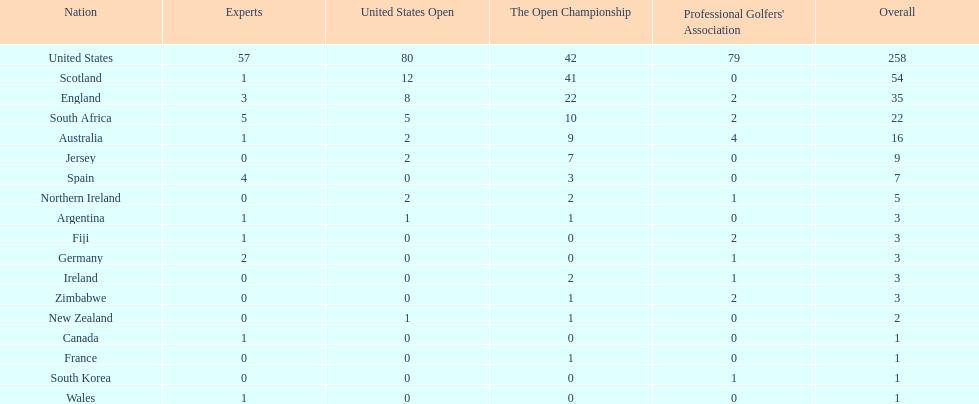In how many nations has the quantity of championship golfers been equal to that of canada? 3. 